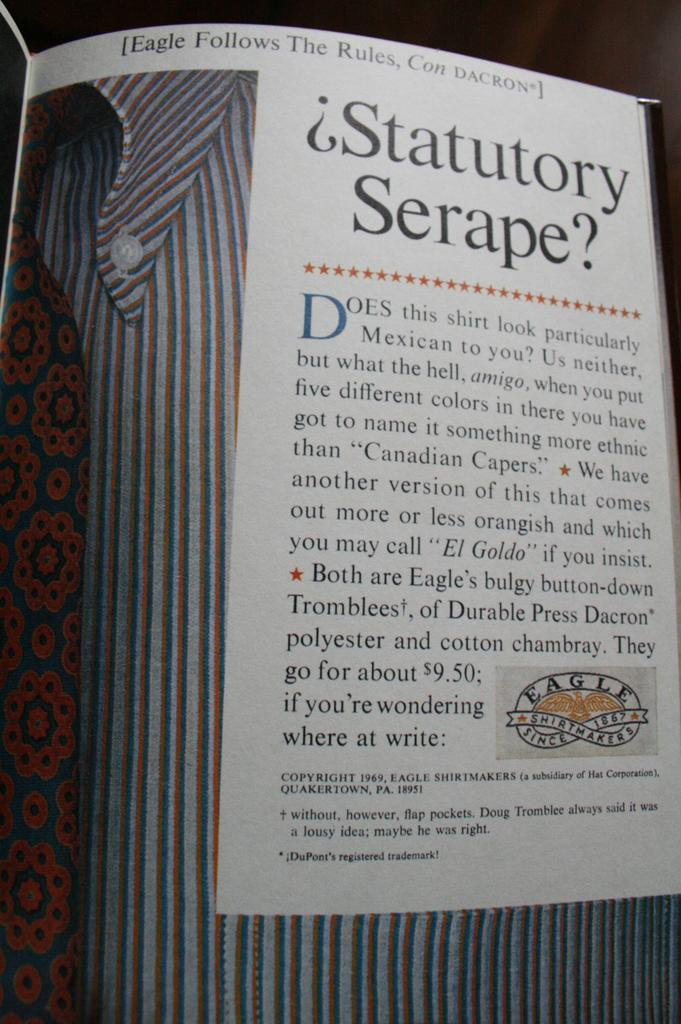<image>
Give a short and clear explanation of the subsequent image. The page of a magazine has Eagle Follows The Rules written at the top. 